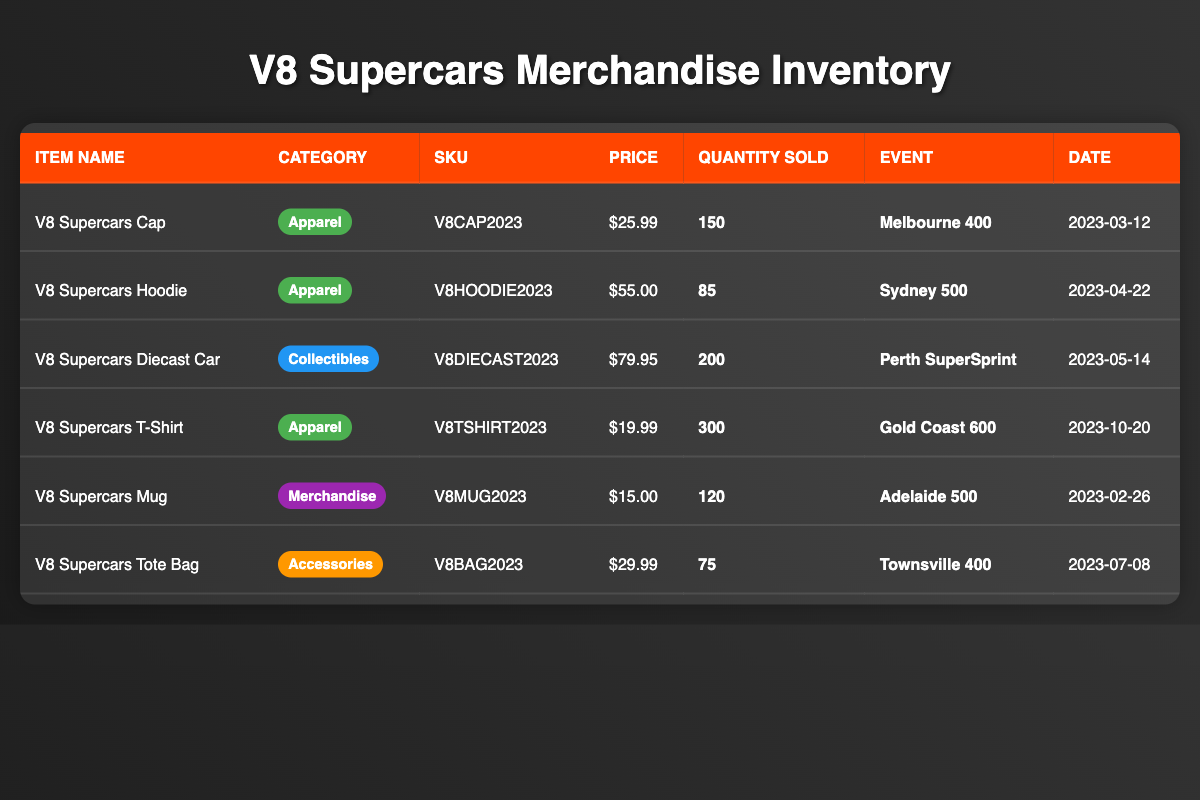What is the total quantity sold for all apparel items? To find the total quantity sold for all apparel items, we look at the "quantity_sold" column for items in the "Apparel" category: V8 Supercars Cap (150) + V8 Supercars Hoodie (85) + V8 Supercars T-Shirt (300) = 535.
Answer: 535 Which item had the highest sales quantity? The item with the highest sales quantity is the V8 Supercars T-Shirt, with a quantity sold of 300, compared to the other items.
Answer: V8 Supercars T-Shirt How much did the V8 Supercars Diecast Car sell for? The price of the V8 Supercars Diecast Car is listed in the "price" column as $79.95.
Answer: $79.95 Is the average price of apparel items greater than $30? The prices of apparel items are: V8 Supercars Cap ($25.99), V8 Supercars Hoodie ($55.00), and V8 Supercars T-Shirt ($19.99). Their average price is (25.99 + 55.00 + 19.99) / 3 = $33.33, which is greater than $30.
Answer: Yes What is the total revenue generated from the sales of the V8 Supercars Mug? Revenue is calculated by multiplying the price ($15.00) by the quantity sold (120). Therefore, total revenue is 15.00 * 120 = $1,800.
Answer: $1,800 Did any event see more than 200 items sold in merchandise? The only event with more than 200 items sold is the Perth SuperSprint (200), while all others have fewer, such as Gold Coast 600 (300) - but that value doesn't surpass 200 sold.
Answer: No How many accessories were sold at the Townsville 400? The table indicates that the V8 Supercars Tote Bag, categorized as accessories, sold 75 units during the Townsville 400 event.
Answer: 75 Which category sold the least number of items? By reviewing the quantities sold across categories, we see Accessories (75) had fewer total sales compared to Apparel (535) and Collectibles (200). Therefore, Accessories are the least sold.
Answer: Accessories What is the total revenue generated from the V8 Supercars Caps sold at the Melbourne 400? The revenue from V8 Supercars Caps can be found by multiplying the quantity sold (150) by its price ($25.99). Thus, total revenue is 150 * 25.99 = $3,898.50.
Answer: $3,898.50 